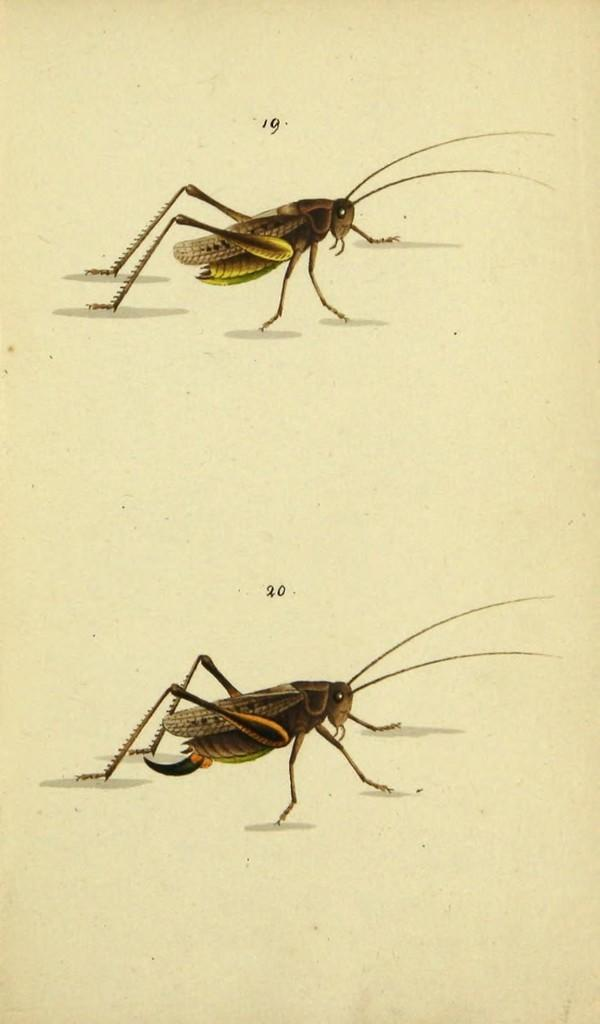What is the main subject of the picture? The main subject of the picture is a paper. What is depicted on the paper? The paper contains a painting. What is shown in the painting? The painting depicts two insects. What are the characteristics of the insects in the painting? The insects have antennae, legs, eyes, and wings. What type of noise can be heard coming from the insects in the image? There is no sound present in the image, so it is not possible to determine what noise, if any, might be heard from the insects. 